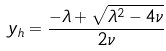Convert formula to latex. <formula><loc_0><loc_0><loc_500><loc_500>y _ { h } = \frac { - \lambda + \sqrt { \lambda ^ { 2 } - 4 \nu } } { 2 \nu }</formula> 